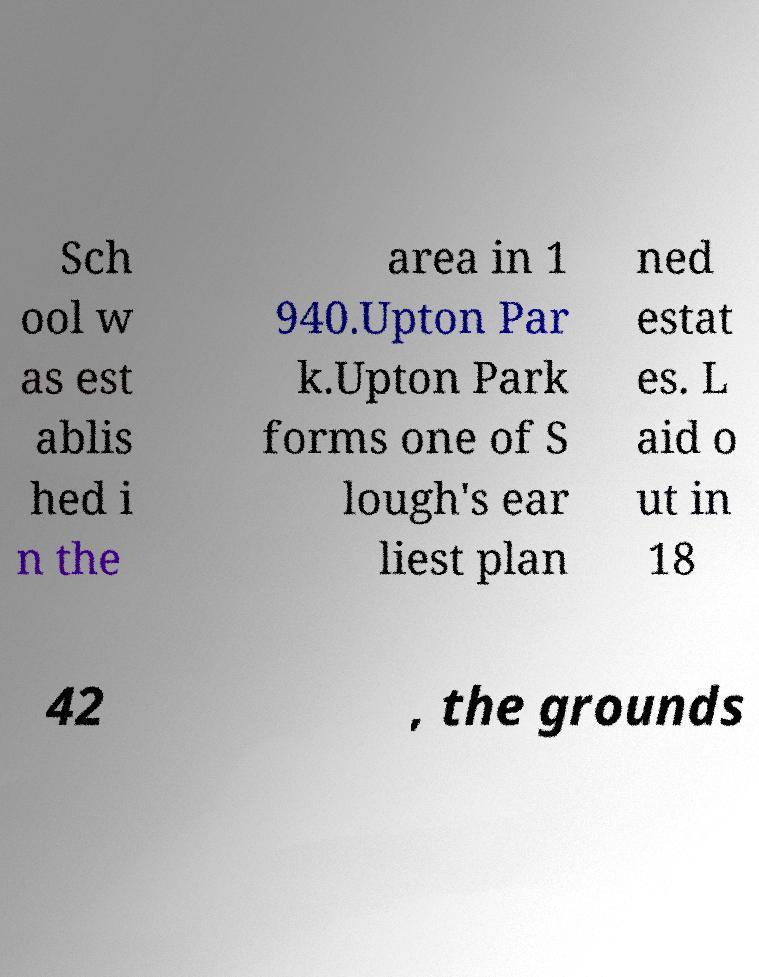Could you assist in decoding the text presented in this image and type it out clearly? Sch ool w as est ablis hed i n the area in 1 940.Upton Par k.Upton Park forms one of S lough's ear liest plan ned estat es. L aid o ut in 18 42 , the grounds 